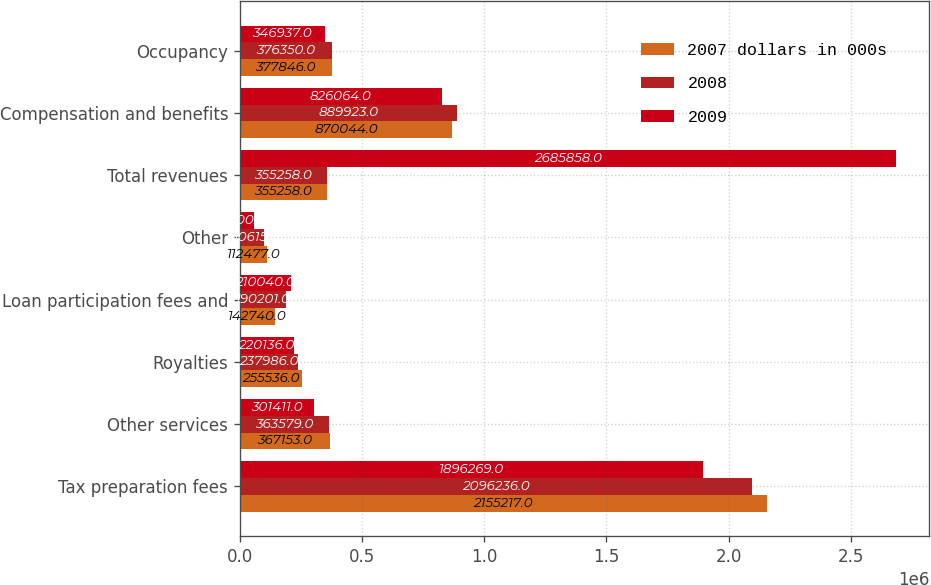<chart> <loc_0><loc_0><loc_500><loc_500><stacked_bar_chart><ecel><fcel>Tax preparation fees<fcel>Other services<fcel>Royalties<fcel>Loan participation fees and<fcel>Other<fcel>Total revenues<fcel>Compensation and benefits<fcel>Occupancy<nl><fcel>2007 dollars in 000s<fcel>2.15522e+06<fcel>367153<fcel>255536<fcel>142740<fcel>112477<fcel>355258<fcel>870044<fcel>377846<nl><fcel>2008<fcel>2.09624e+06<fcel>363579<fcel>237986<fcel>190201<fcel>100615<fcel>355258<fcel>889923<fcel>376350<nl><fcel>2009<fcel>1.89627e+06<fcel>301411<fcel>220136<fcel>210040<fcel>58002<fcel>2.68586e+06<fcel>826064<fcel>346937<nl></chart> 